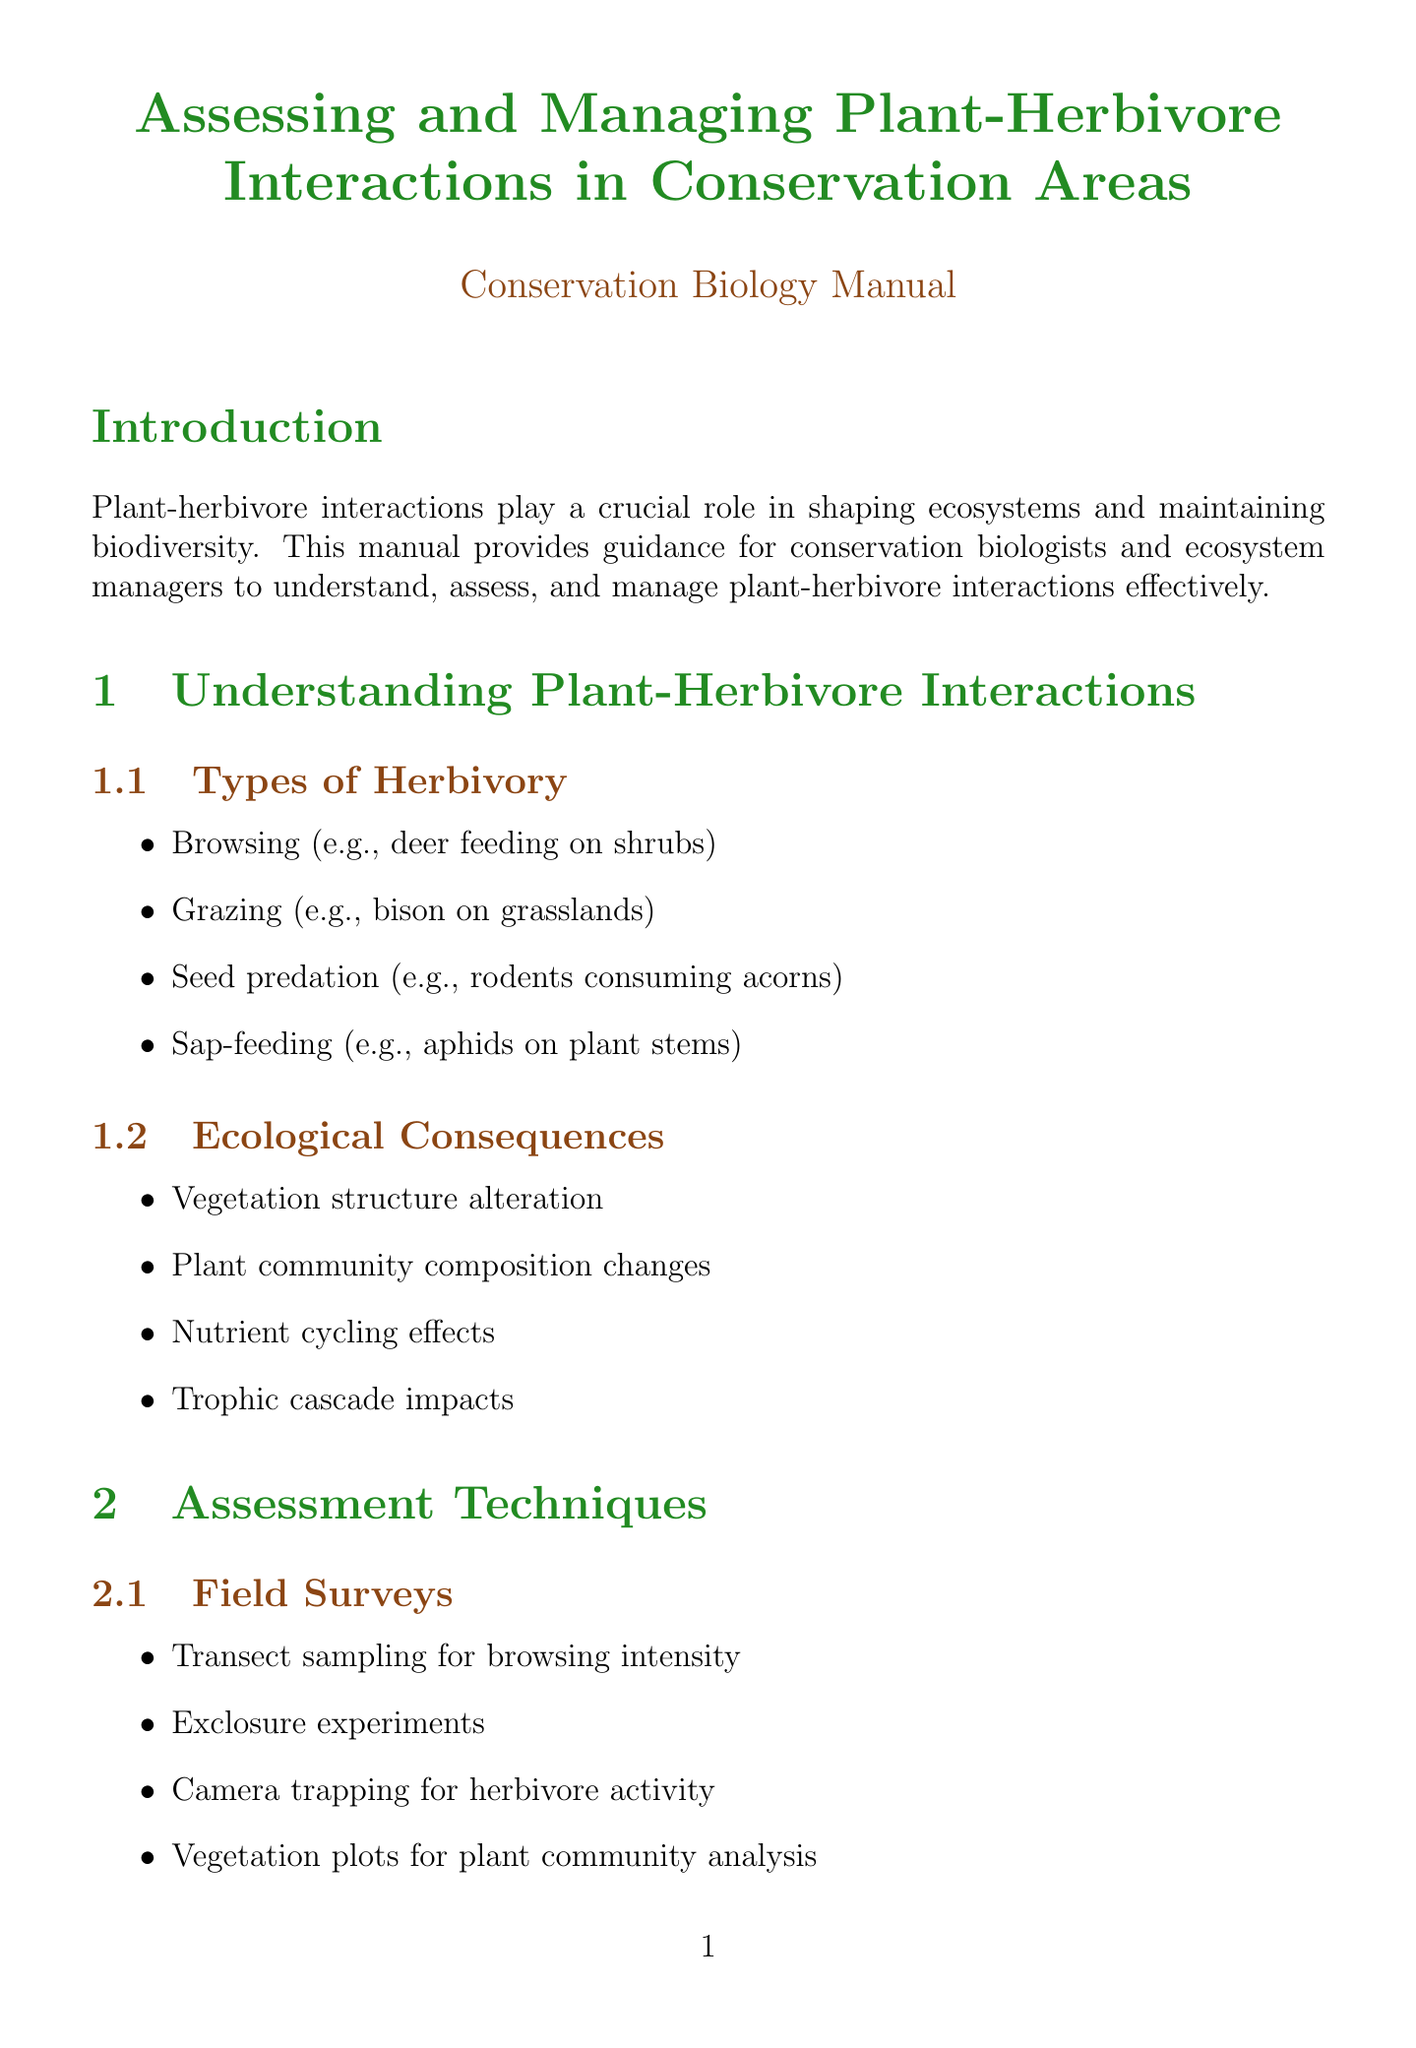What is the title of the manual? The title is mentioned at the beginning of the document, which is "Assessing and Managing Plant-Herbivore Interactions in Conservation Areas."
Answer: Assessing and Managing Plant-Herbivore Interactions in Conservation Areas What are the types of herbivory discussed? The document lists various types of herbivory under the section "Types of Herbivory," including browsing, grazing, seed predation, and sap-feeding.
Answer: Browsing, Grazing, Seed predation, Sap-feeding What is one method of herbivore population control? The manual discusses several management strategies, one of which includes culling programs.
Answer: Culling programs How many successful intervention case studies are provided? The section "Successful Interventions" includes four specific case studies related to plant-herbivore interactions.
Answer: Four What does the term "trophic cascade" refer to in the glossary? The glossary defines "trophic cascade" to elucidate the indirect effects of predators on plants through herbivore control.
Answer: Indirect effects of predators on plants through herbivore control What is a key component of the adaptive management framework? The document outlines several elements of adaptive management, and one key component is setting clear management objectives.
Answer: Setting clear management objectives Name one type of laboratory analysis mentioned. The section on laboratory analysis lists different techniques, one of which is stable isotope analysis for trophic interactions.
Answer: Stable isotope analysis What is one example of habitat manipulation? The management strategies section provides various examples; one mentioned is prescribed burning to promote plant diversity.
Answer: Prescribed burning to promote plant diversity What is the purpose of the manual? The introduction states that the purpose of the manual is to provide guidance for conservation biologists and ecosystem managers.
Answer: Guidance for conservation biologists and ecosystem managers 